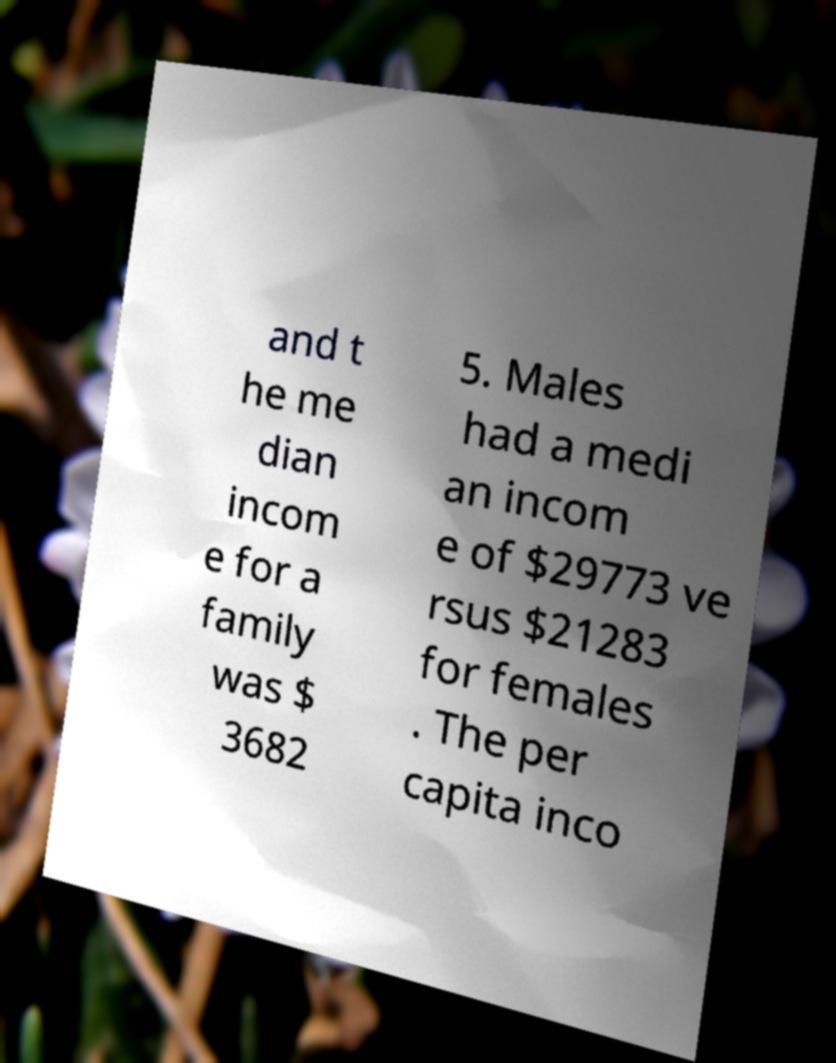Could you assist in decoding the text presented in this image and type it out clearly? and t he me dian incom e for a family was $ 3682 5. Males had a medi an incom e of $29773 ve rsus $21283 for females . The per capita inco 